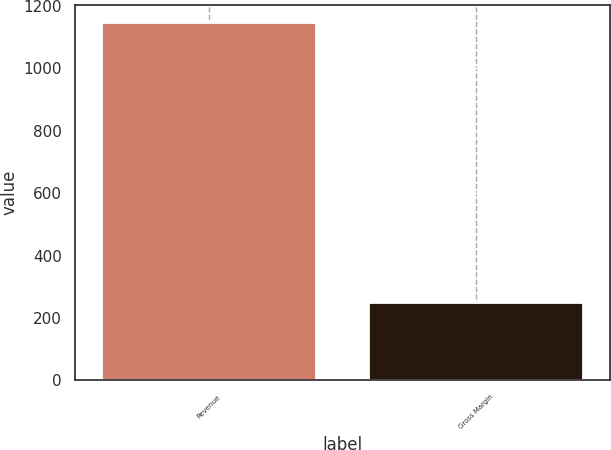Convert chart. <chart><loc_0><loc_0><loc_500><loc_500><bar_chart><fcel>Revenue<fcel>Gross Margin<nl><fcel>1145<fcel>249<nl></chart> 